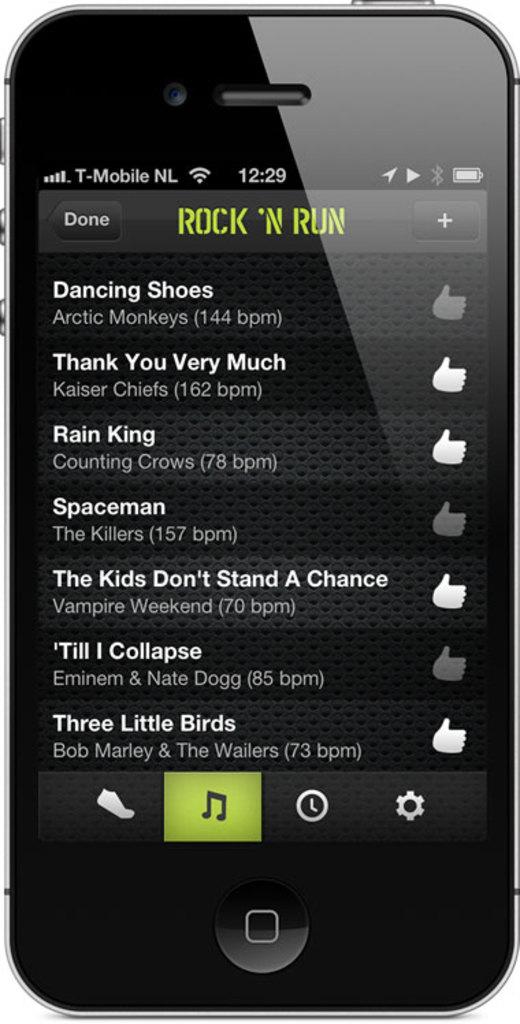What is the title of this playlist?
Offer a terse response. Rock 'n run. Whats the name of the first song on the playlist?
Your answer should be very brief. Dancing shoes. 